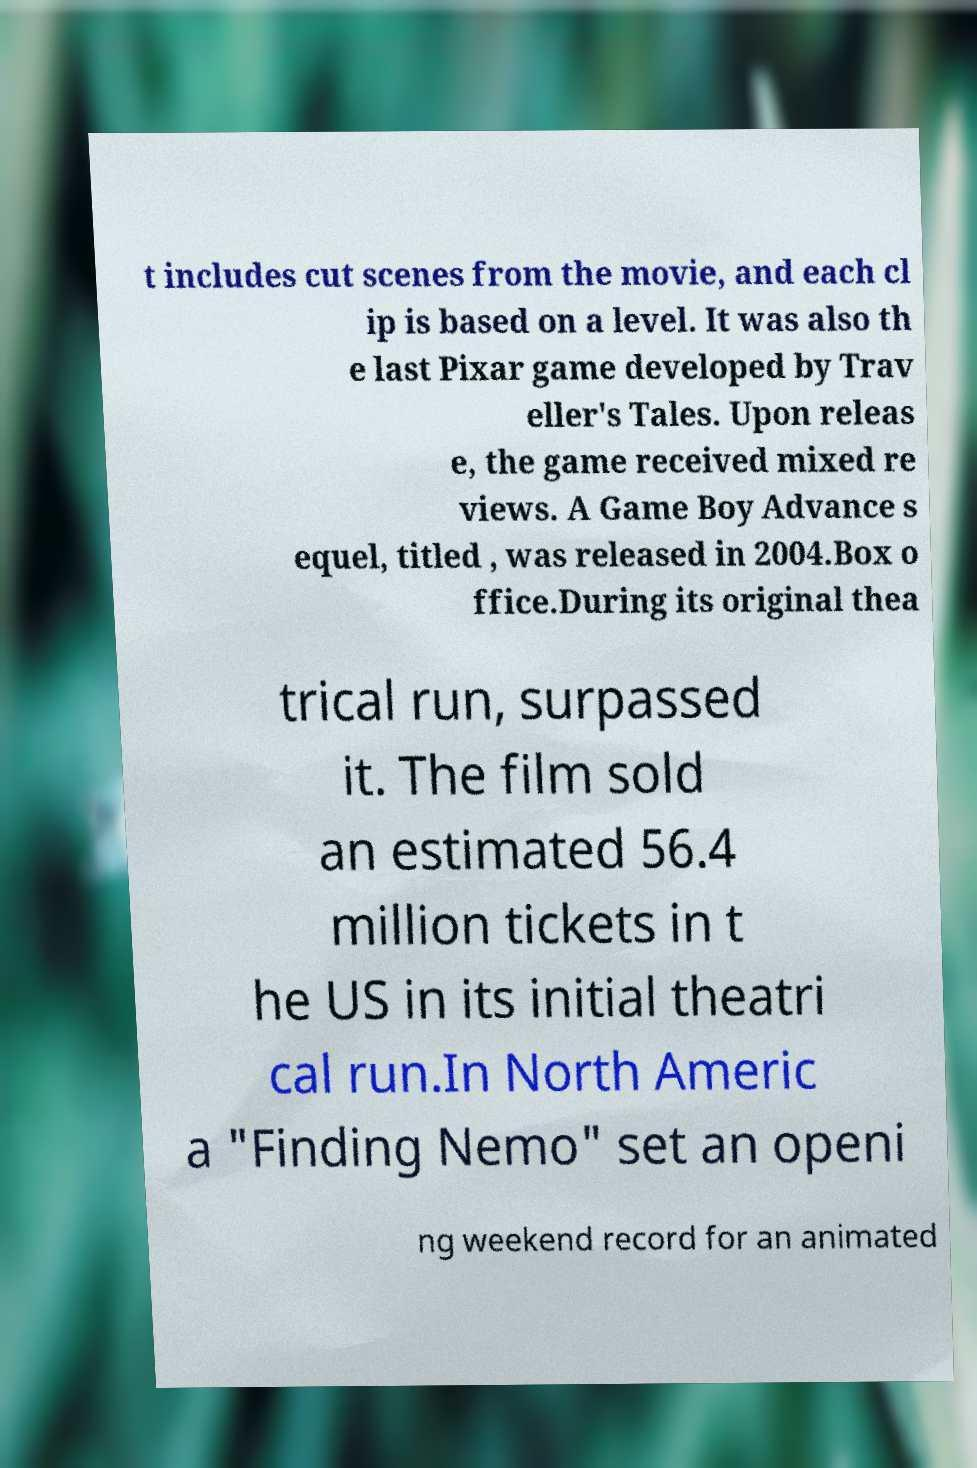Could you extract and type out the text from this image? t includes cut scenes from the movie, and each cl ip is based on a level. It was also th e last Pixar game developed by Trav eller's Tales. Upon releas e, the game received mixed re views. A Game Boy Advance s equel, titled , was released in 2004.Box o ffice.During its original thea trical run, surpassed it. The film sold an estimated 56.4 million tickets in t he US in its initial theatri cal run.In North Americ a "Finding Nemo" set an openi ng weekend record for an animated 